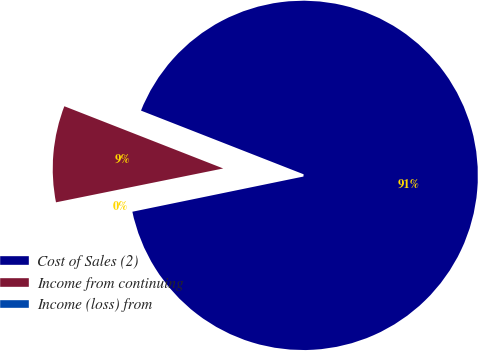Convert chart. <chart><loc_0><loc_0><loc_500><loc_500><pie_chart><fcel>Cost of Sales (2)<fcel>Income from continuing<fcel>Income (loss) from<nl><fcel>90.83%<fcel>9.12%<fcel>0.05%<nl></chart> 